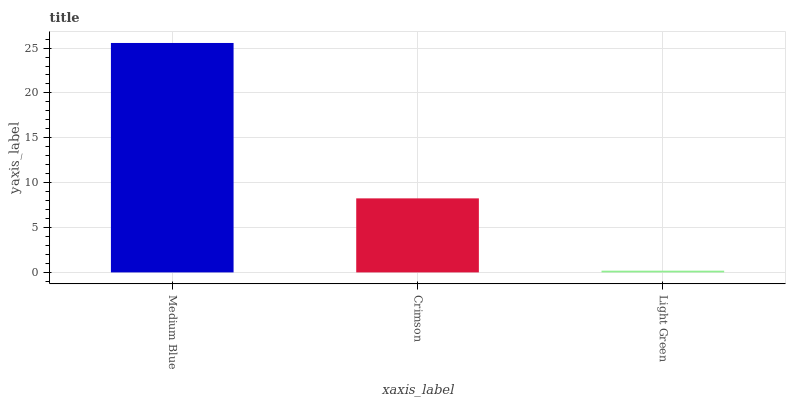Is Light Green the minimum?
Answer yes or no. Yes. Is Medium Blue the maximum?
Answer yes or no. Yes. Is Crimson the minimum?
Answer yes or no. No. Is Crimson the maximum?
Answer yes or no. No. Is Medium Blue greater than Crimson?
Answer yes or no. Yes. Is Crimson less than Medium Blue?
Answer yes or no. Yes. Is Crimson greater than Medium Blue?
Answer yes or no. No. Is Medium Blue less than Crimson?
Answer yes or no. No. Is Crimson the high median?
Answer yes or no. Yes. Is Crimson the low median?
Answer yes or no. Yes. Is Light Green the high median?
Answer yes or no. No. Is Light Green the low median?
Answer yes or no. No. 